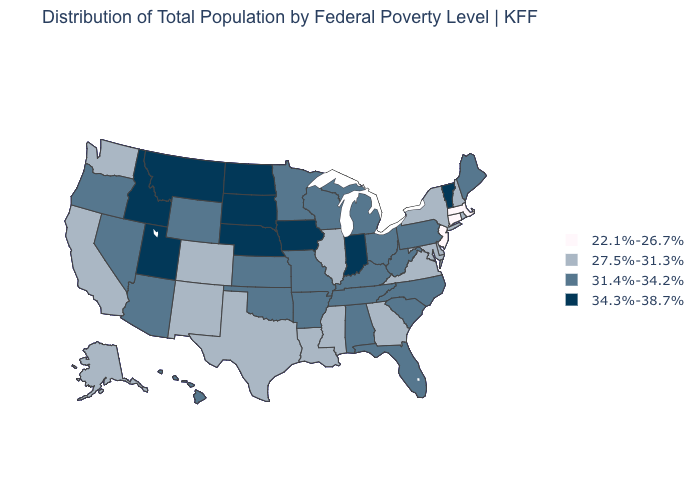Among the states that border Florida , does Georgia have the lowest value?
Keep it brief. Yes. What is the value of Maine?
Give a very brief answer. 31.4%-34.2%. What is the lowest value in the USA?
Give a very brief answer. 22.1%-26.7%. Name the states that have a value in the range 27.5%-31.3%?
Short answer required. Alaska, California, Colorado, Delaware, Georgia, Illinois, Louisiana, Maryland, Mississippi, New Hampshire, New Mexico, New York, Rhode Island, Texas, Virginia, Washington. Name the states that have a value in the range 34.3%-38.7%?
Be succinct. Idaho, Indiana, Iowa, Montana, Nebraska, North Dakota, South Dakota, Utah, Vermont. Does North Dakota have a higher value than Nebraska?
Quick response, please. No. Name the states that have a value in the range 34.3%-38.7%?
Give a very brief answer. Idaho, Indiana, Iowa, Montana, Nebraska, North Dakota, South Dakota, Utah, Vermont. What is the lowest value in the USA?
Keep it brief. 22.1%-26.7%. What is the lowest value in the USA?
Be succinct. 22.1%-26.7%. What is the value of New Jersey?
Give a very brief answer. 22.1%-26.7%. What is the value of Connecticut?
Be succinct. 22.1%-26.7%. Among the states that border Wisconsin , does Iowa have the lowest value?
Be succinct. No. Among the states that border New York , which have the highest value?
Give a very brief answer. Vermont. Which states have the lowest value in the USA?
Concise answer only. Connecticut, Massachusetts, New Jersey. What is the highest value in the West ?
Be succinct. 34.3%-38.7%. 